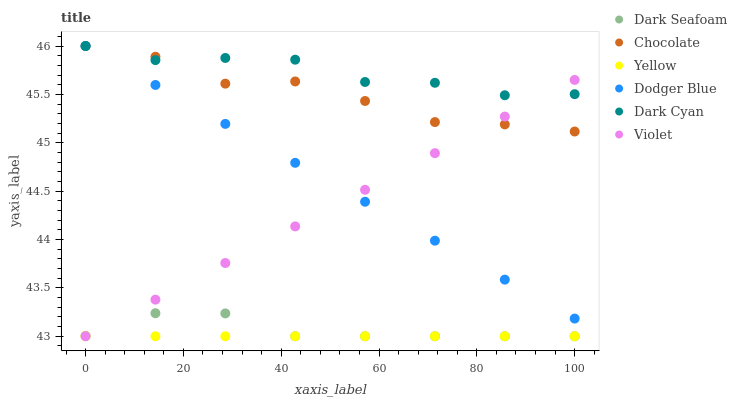Does Yellow have the minimum area under the curve?
Answer yes or no. Yes. Does Dark Cyan have the maximum area under the curve?
Answer yes or no. Yes. Does Chocolate have the minimum area under the curve?
Answer yes or no. No. Does Chocolate have the maximum area under the curve?
Answer yes or no. No. Is Yellow the smoothest?
Answer yes or no. Yes. Is Chocolate the roughest?
Answer yes or no. Yes. Is Dark Seafoam the smoothest?
Answer yes or no. No. Is Dark Seafoam the roughest?
Answer yes or no. No. Does Yellow have the lowest value?
Answer yes or no. Yes. Does Chocolate have the lowest value?
Answer yes or no. No. Does Dark Cyan have the highest value?
Answer yes or no. Yes. Does Dark Seafoam have the highest value?
Answer yes or no. No. Is Yellow less than Dark Cyan?
Answer yes or no. Yes. Is Chocolate greater than Yellow?
Answer yes or no. Yes. Does Violet intersect Dark Seafoam?
Answer yes or no. Yes. Is Violet less than Dark Seafoam?
Answer yes or no. No. Is Violet greater than Dark Seafoam?
Answer yes or no. No. Does Yellow intersect Dark Cyan?
Answer yes or no. No. 